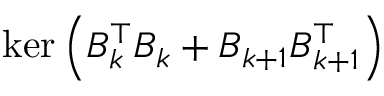Convert formula to latex. <formula><loc_0><loc_0><loc_500><loc_500>\ker \left ( B _ { k } ^ { \top } B _ { k } + B _ { k + 1 } B _ { k + 1 } ^ { \top } \right )</formula> 